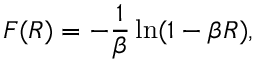Convert formula to latex. <formula><loc_0><loc_0><loc_500><loc_500>F ( R ) = - \frac { 1 } { \beta } \ln ( 1 - \beta R ) ,</formula> 